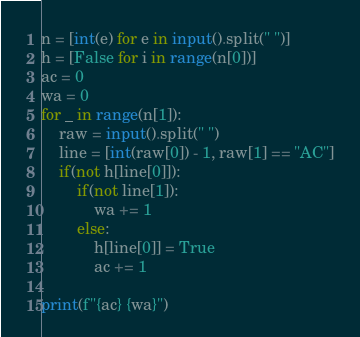Convert code to text. <code><loc_0><loc_0><loc_500><loc_500><_Python_>n = [int(e) for e in input().split(" ")]
h = [False for i in range(n[0])]
ac = 0
wa = 0
for _ in range(n[1]):
    raw = input().split(" ")
    line = [int(raw[0]) - 1, raw[1] == "AC"]
    if(not h[line[0]]):
        if(not line[1]):
            wa += 1
        else:
            h[line[0]] = True
            ac += 1

print(f"{ac} {wa}")</code> 